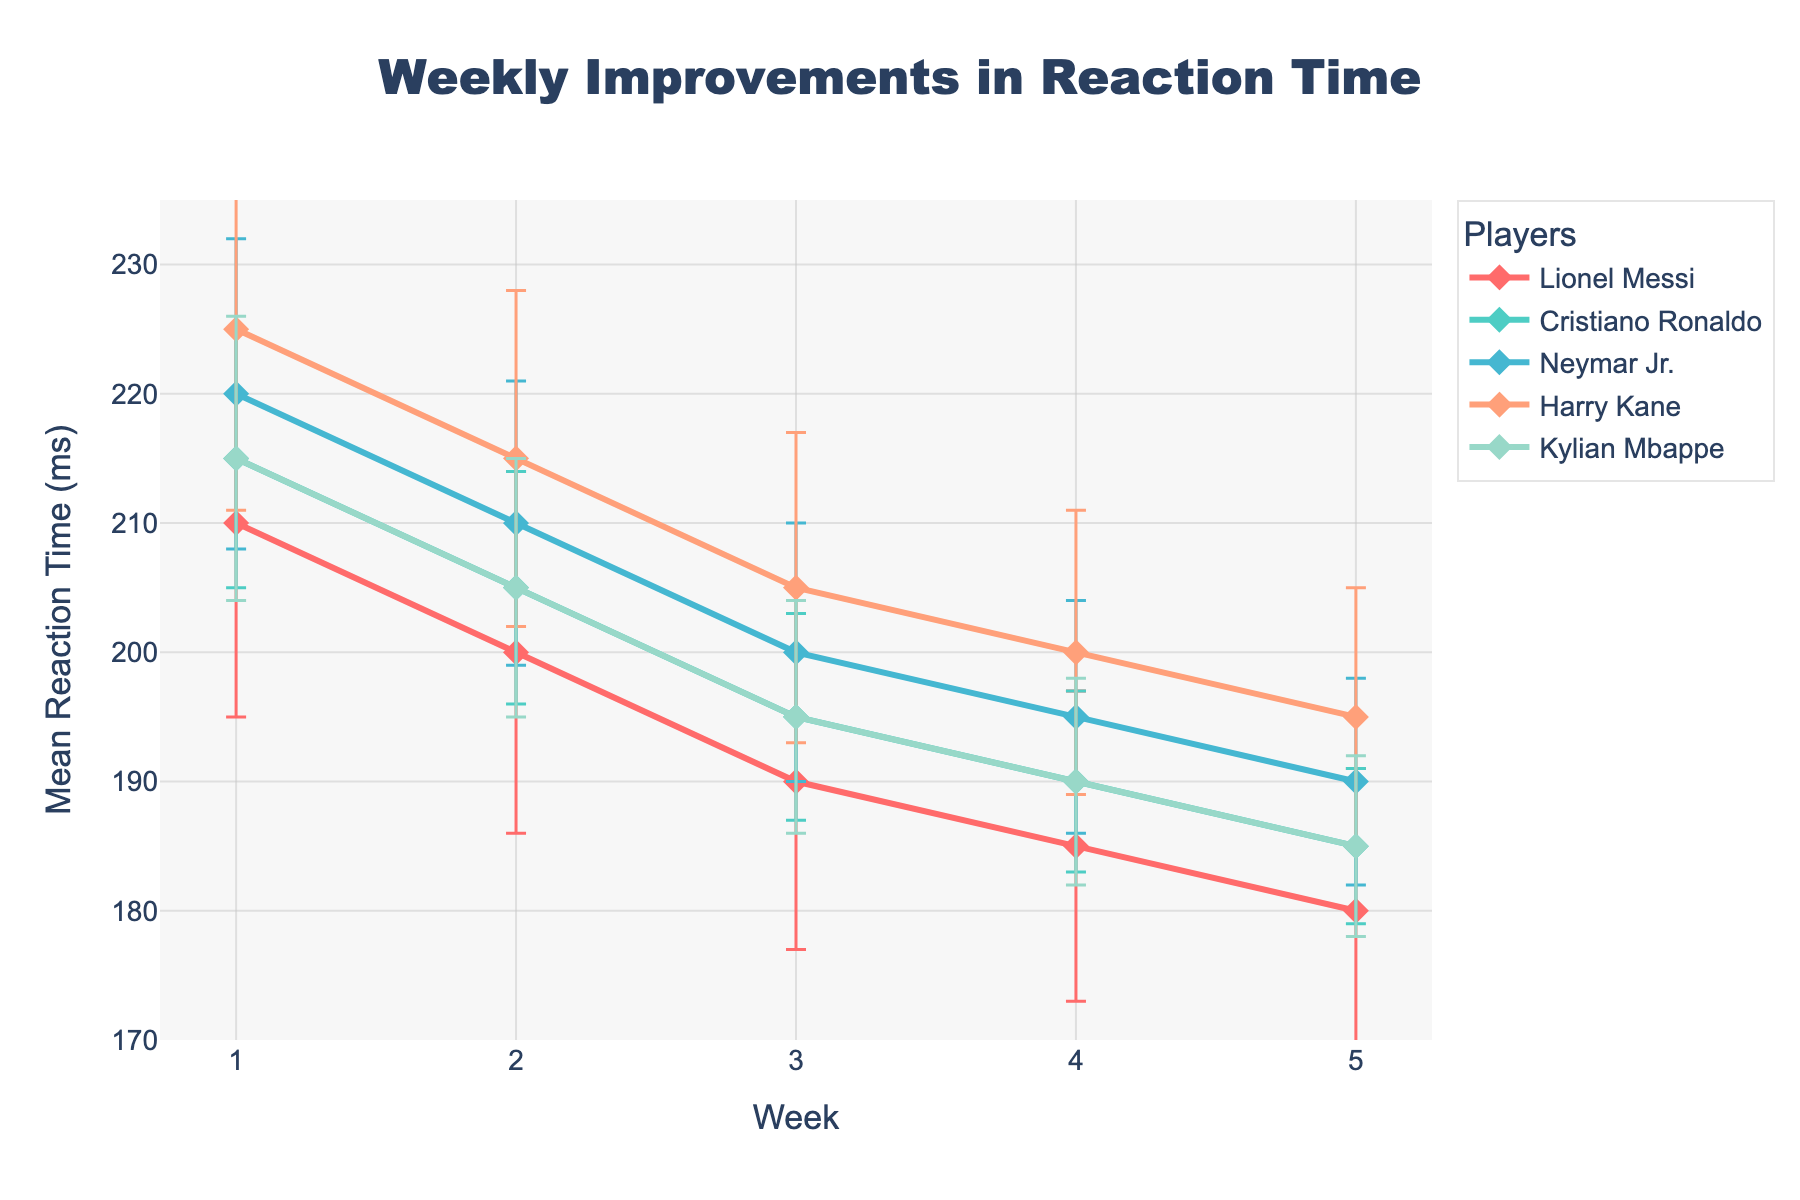What's the title of the figure? The title of the figure is usually prominently displayed at the top center of the plot. You can read it directly from there.
Answer: Weekly Improvements in Reaction Time What does the x-axis represent? The x-axis is labeled to show what it represents. Here, it is labeled 'Week', indicating different weeks of measuring reaction times.
Answer: Week Which player has the lowest mean reaction time in Week 1? Look at Week 1's data points for all players. Lionel Messi has the lowest mean reaction time of 210 milliseconds.
Answer: Lionel Messi How did Neymar Jr.'s reaction time change from Week 1 to Week 5? Find Neymar Jr.’s reaction times for Week 1 and Week 5. His reaction time decreased from 220 milliseconds in Week 1 to 190 milliseconds in Week 5.
Answer: Decreased from 220 to 190 ms Which week shows the largest improvement in reaction time for Cristiano Ronaldo? Look at Cristiano Ronaldo's reaction times for each week. Calculate the differences between consecutive weeks. The largest improvement is from Week 4 to Week 5, with a reduction from 190 ms to 185 ms (5 ms).
Answer: Week 4 to Week 5 Which player consistently showed improvements week over week? Check each player's reaction times across all weeks. All players show improvement, but Lionel Messi's reaction time decreases continuously from Week 1 to Week 5.
Answer: Lionel Messi What trend is observable in Kylian Mbappe’s reaction time over the weeks? Trace Kylian Mbappe’s reaction time from Week 1 to Week 5. There is a consistent decrease in his reaction time each week, signifying improvement.
Answer: Decreasing trend Compare the reaction times of Harry Kane and Neymar Jr. in Week 3. Who has a better reaction time and by how much? Check Week 3 for both players. Harry Kane's reaction time is 205 ms; Neymar Jr.'s is 200 ms. Neymar Jr. has a better reaction time by 5 milliseconds.
Answer: Neymar Jr. by 5 ms Which player had the smallest variability in reaction time measurements? Look at the standard deviation values for each player across all weeks. Cristiano Ronaldo consistently has smaller standard deviations, indicating lower variability in his reaction times.
Answer: Cristiano Ronaldo 